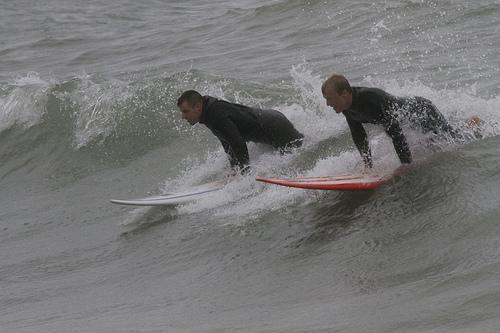How many people in the image?
Give a very brief answer. 2. 